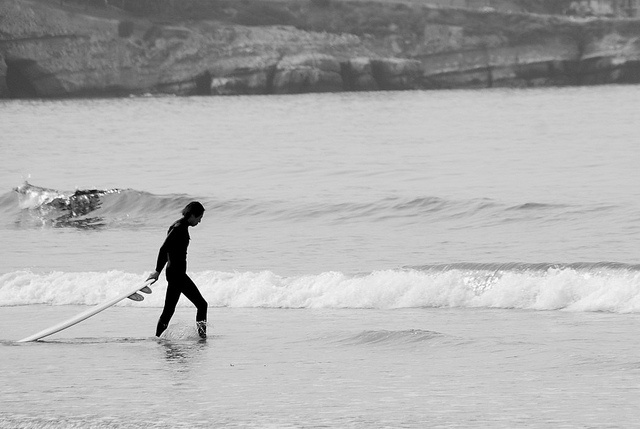Describe the objects in this image and their specific colors. I can see people in gray, black, darkgray, and lightgray tones and surfboard in gray, lightgray, darkgray, and black tones in this image. 